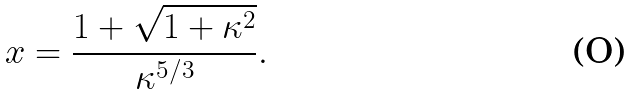Convert formula to latex. <formula><loc_0><loc_0><loc_500><loc_500>x = \frac { 1 + \sqrt { 1 + \kappa ^ { 2 } } } { \kappa ^ { 5 / 3 } } .</formula> 